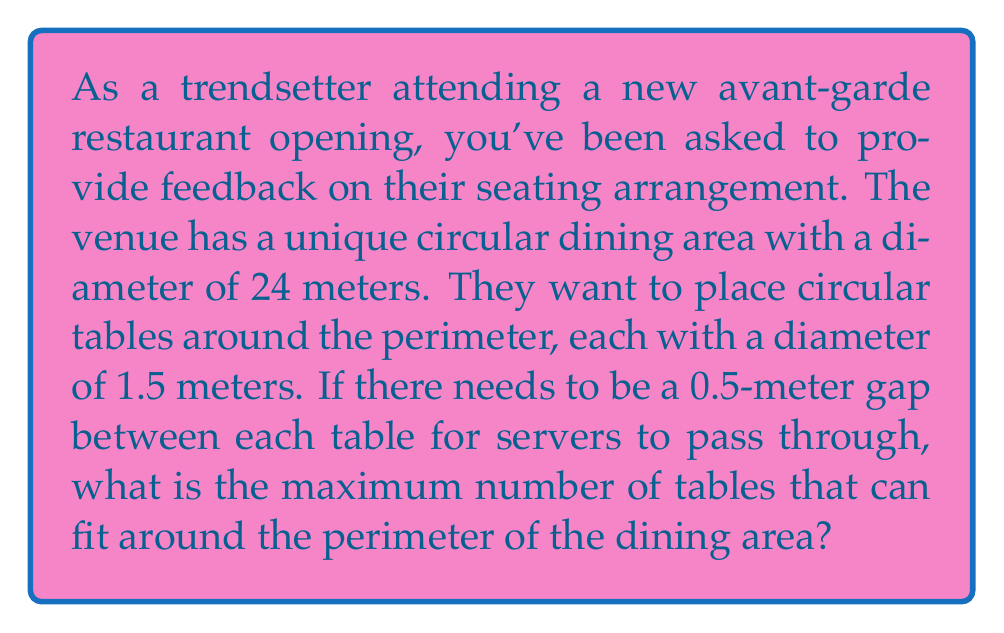Could you help me with this problem? Let's approach this step-by-step:

1) First, we need to calculate the circumference of the dining area. The formula for circumference is:
   $$C = \pi d$$
   where $d$ is the diameter.

2) Plugging in our values:
   $$C = \pi \times 24 = 75.4 \text{ meters}$$

3) Now, we need to determine how much space each table setup takes along the circumference. This includes the table itself plus the gap:
   $$\text{Space per table} = 1.5 \text{ m (table)} + 0.5 \text{ m (gap)} = 2 \text{ meters}$$

4) To find the maximum number of tables, we divide the circumference by the space per table:
   $$\text{Number of tables} = \frac{\text{Circumference}}{\text{Space per table}} = \frac{75.4}{2} = 37.7$$

5) Since we can't have a fractional number of tables, we round down to the nearest whole number.

This arrangement leaves some extra space, which can be distributed evenly between the tables to make the gaps slightly larger than 0.5 meters, creating a more spacious feel.
Answer: The maximum number of tables that can fit around the perimeter is 37. 